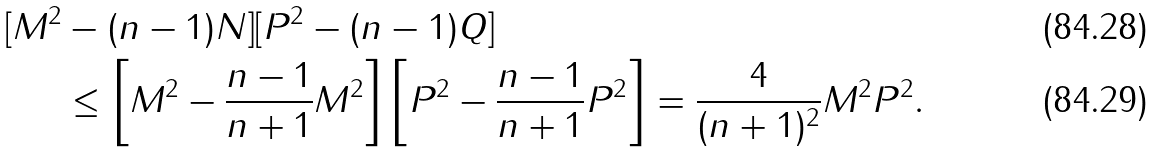Convert formula to latex. <formula><loc_0><loc_0><loc_500><loc_500>[ M ^ { 2 } & - ( n - 1 ) N ] [ P ^ { 2 } - ( n - 1 ) Q ] \\ & \leq \left [ M ^ { 2 } - \frac { n - 1 } { n + 1 } M ^ { 2 } \right ] \left [ P ^ { 2 } - \frac { n - 1 } { n + 1 } P ^ { 2 } \right ] = \frac { 4 } { ( n + 1 ) ^ { 2 } } M ^ { 2 } P ^ { 2 } .</formula> 